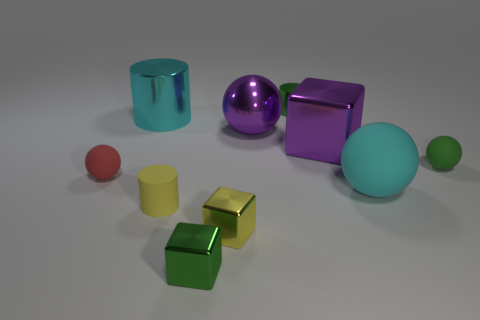Subtract all big metallic spheres. How many spheres are left? 3 Subtract all red spheres. How many spheres are left? 3 Subtract all cylinders. How many objects are left? 7 Subtract all large purple blocks. Subtract all tiny green shiny cylinders. How many objects are left? 8 Add 7 cyan rubber objects. How many cyan rubber objects are left? 8 Add 8 big matte spheres. How many big matte spheres exist? 9 Subtract 1 purple cubes. How many objects are left? 9 Subtract 4 balls. How many balls are left? 0 Subtract all gray balls. Subtract all brown cubes. How many balls are left? 4 Subtract all blue cylinders. How many cyan blocks are left? 0 